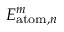<formula> <loc_0><loc_0><loc_500><loc_500>E _ { a t o m , n } ^ { m }</formula> 